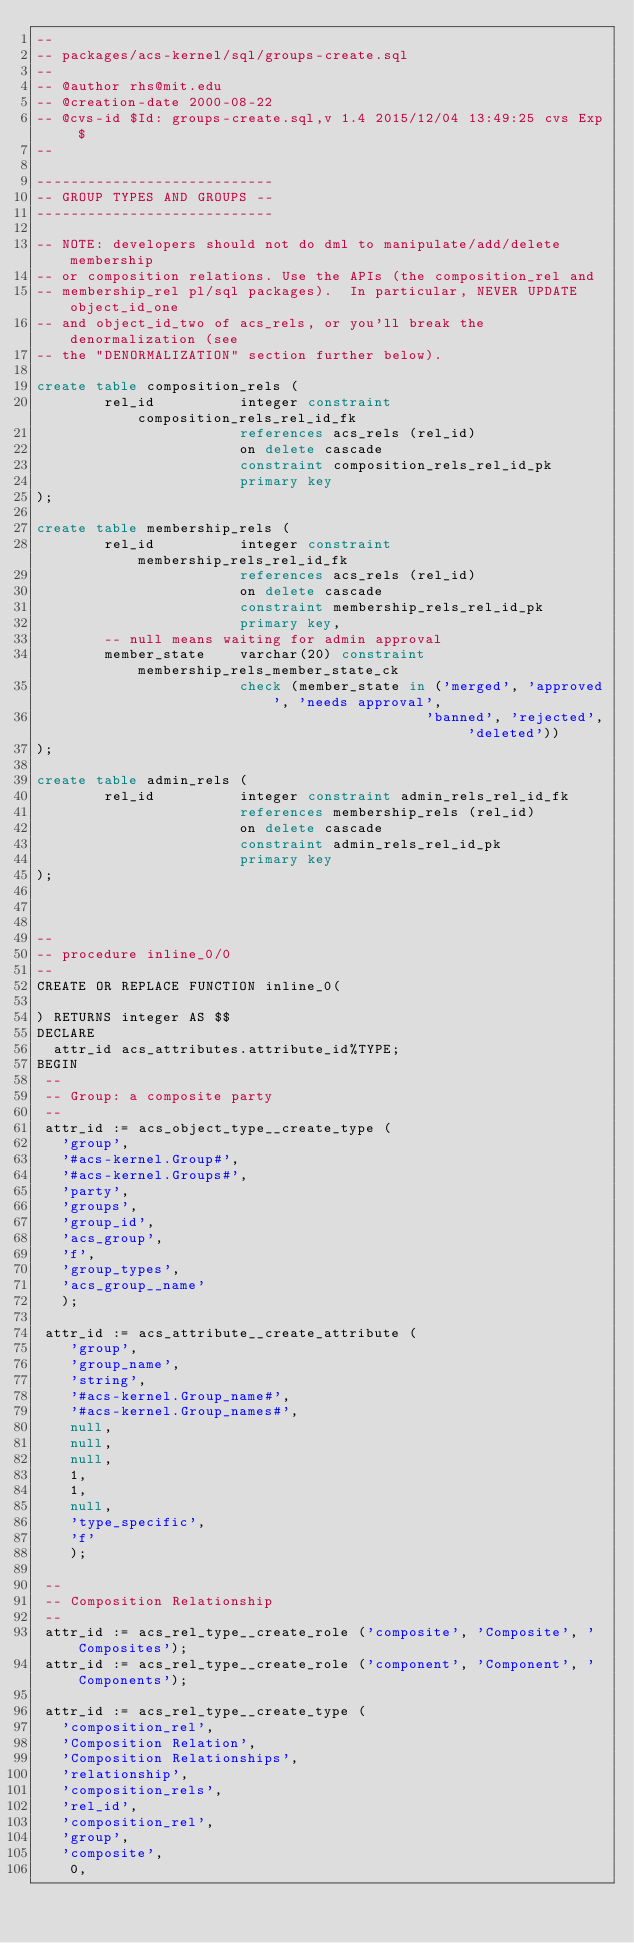Convert code to text. <code><loc_0><loc_0><loc_500><loc_500><_SQL_>--
-- packages/acs-kernel/sql/groups-create.sql
--
-- @author rhs@mit.edu
-- @creation-date 2000-08-22
-- @cvs-id $Id: groups-create.sql,v 1.4 2015/12/04 13:49:25 cvs Exp $
--

----------------------------
-- GROUP TYPES AND GROUPS --
----------------------------
 
-- NOTE: developers should not do dml to manipulate/add/delete membership
-- or composition relations. Use the APIs (the composition_rel and 
-- membership_rel pl/sql packages).  In particular, NEVER UPDATE object_id_one
-- and object_id_two of acs_rels, or you'll break the denormalization (see
-- the "DENORMALIZATION" section further below).

create table composition_rels (
        rel_id          integer constraint composition_rels_rel_id_fk
                        references acs_rels (rel_id)
                        on delete cascade
                        constraint composition_rels_rel_id_pk
                        primary key
);

create table membership_rels (
        rel_id          integer constraint membership_rels_rel_id_fk
                        references acs_rels (rel_id)
                        on delete cascade
                        constraint membership_rels_rel_id_pk
                        primary key,
        -- null means waiting for admin approval
        member_state    varchar(20) constraint membership_rels_member_state_ck
                        check (member_state in ('merged', 'approved', 'needs approval',
                                              'banned', 'rejected', 'deleted'))
);

create table admin_rels (
        rel_id          integer constraint admin_rels_rel_id_fk
                        references membership_rels (rel_id)
                        on delete cascade
                        constraint admin_rels_rel_id_pk
                        primary key
);



--
-- procedure inline_0/0
--
CREATE OR REPLACE FUNCTION inline_0(

) RETURNS integer AS $$
DECLARE
  attr_id acs_attributes.attribute_id%TYPE;
BEGIN
 --
 -- Group: a composite party
 --
 attr_id := acs_object_type__create_type (
   'group',
   '#acs-kernel.Group#',
   '#acs-kernel.Groups#',
   'party',
   'groups',
   'group_id',
   'acs_group',
   'f',
   'group_types',
   'acs_group__name'
   );

 attr_id := acs_attribute__create_attribute (
	'group',
	'group_name',
	'string',
	'#acs-kernel.Group_name#',
	'#acs-kernel.Group_names#',
	null,
	null,
	null,
	1,
	1,
	null,
	'type_specific',
	'f'
	);

 --
 -- Composition Relationship
 --
 attr_id := acs_rel_type__create_role ('composite', 'Composite', 'Composites');
 attr_id := acs_rel_type__create_role ('component', 'Component', 'Components');

 attr_id := acs_rel_type__create_type (
   'composition_rel',
   'Composition Relation',
   'Composition Relationships',
   'relationship',
   'composition_rels',
   'rel_id',
   'composition_rel',
   'group',
   'composite',
    0, </code> 